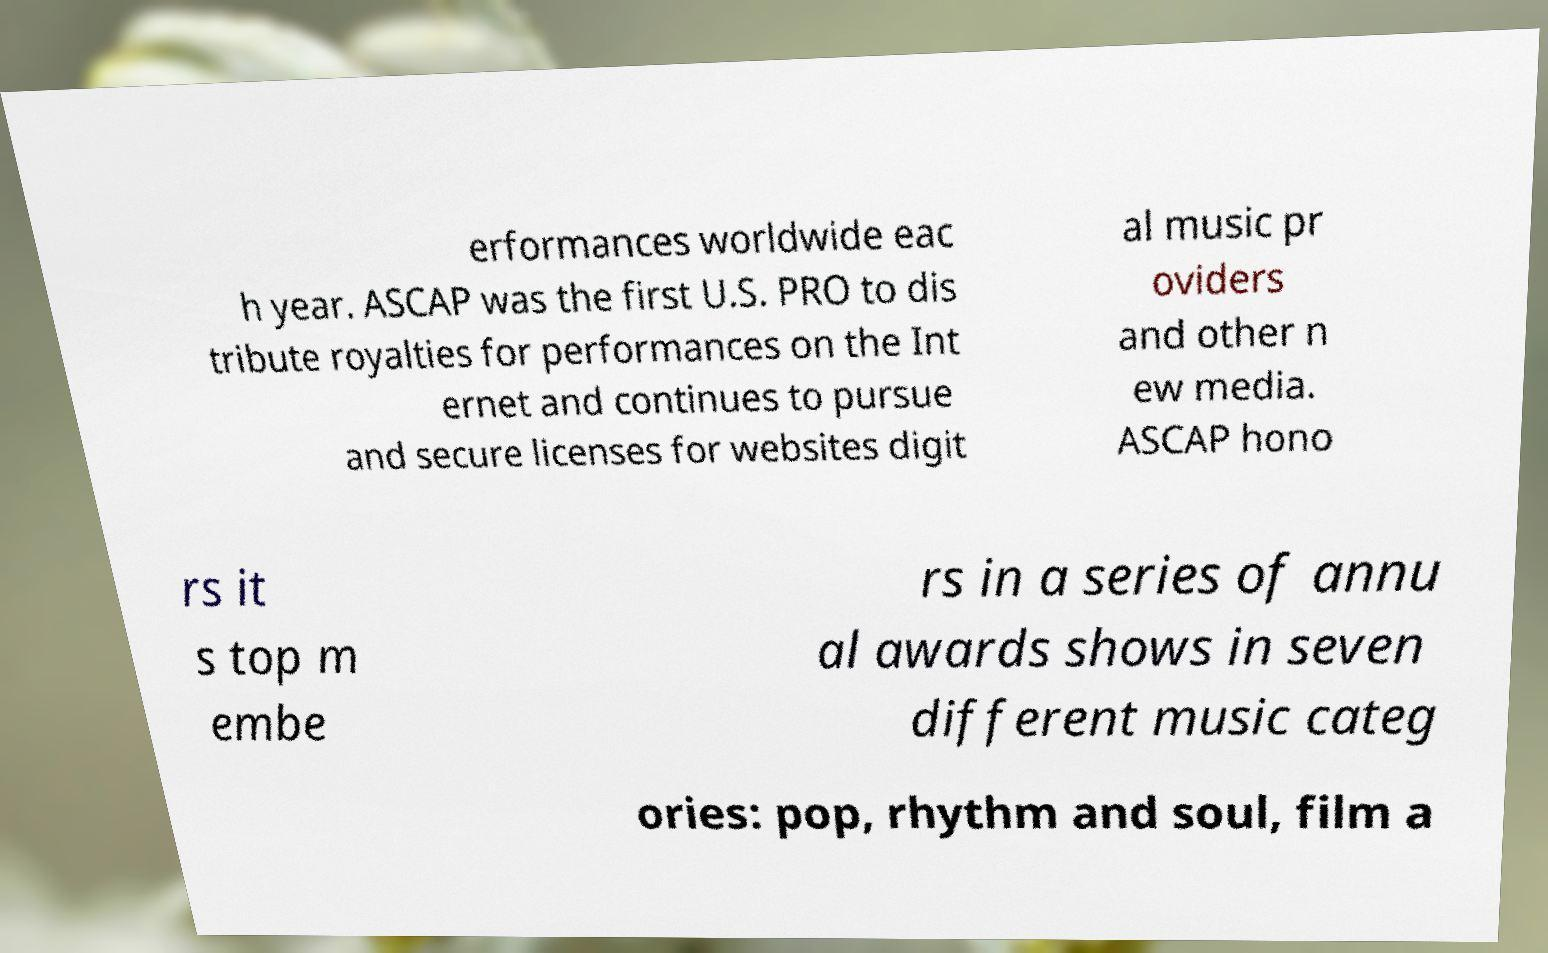Can you read and provide the text displayed in the image?This photo seems to have some interesting text. Can you extract and type it out for me? erformances worldwide eac h year. ASCAP was the first U.S. PRO to dis tribute royalties for performances on the Int ernet and continues to pursue and secure licenses for websites digit al music pr oviders and other n ew media. ASCAP hono rs it s top m embe rs in a series of annu al awards shows in seven different music categ ories: pop, rhythm and soul, film a 